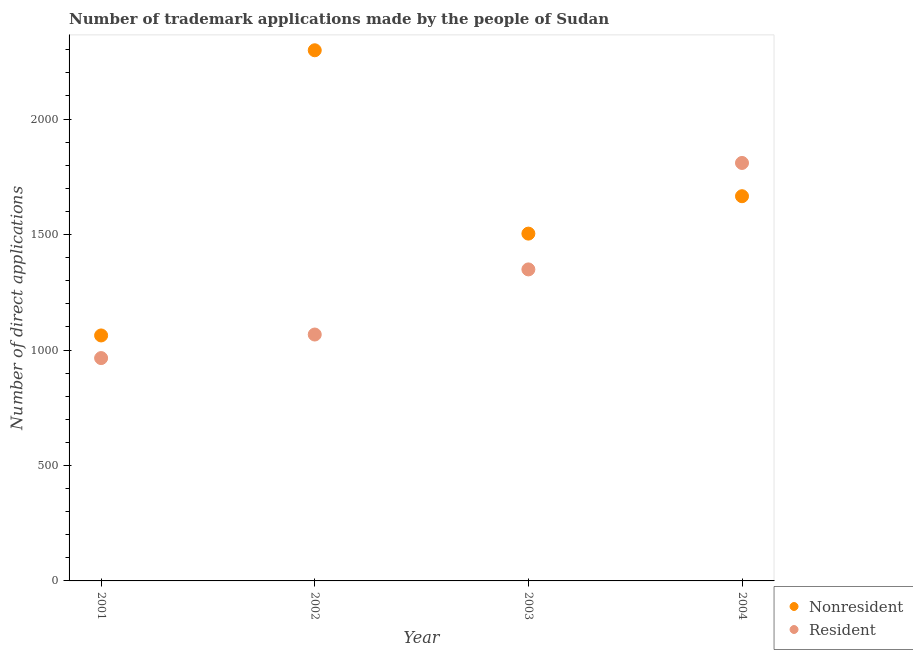How many different coloured dotlines are there?
Provide a short and direct response. 2. What is the number of trademark applications made by residents in 2003?
Your answer should be compact. 1349. Across all years, what is the maximum number of trademark applications made by non residents?
Keep it short and to the point. 2298. Across all years, what is the minimum number of trademark applications made by residents?
Give a very brief answer. 965. In which year was the number of trademark applications made by residents minimum?
Provide a short and direct response. 2001. What is the total number of trademark applications made by non residents in the graph?
Provide a short and direct response. 6531. What is the difference between the number of trademark applications made by residents in 2003 and that in 2004?
Your answer should be compact. -461. What is the difference between the number of trademark applications made by residents in 2003 and the number of trademark applications made by non residents in 2004?
Provide a succinct answer. -317. What is the average number of trademark applications made by residents per year?
Your answer should be compact. 1297.75. In the year 2004, what is the difference between the number of trademark applications made by residents and number of trademark applications made by non residents?
Provide a short and direct response. 144. What is the ratio of the number of trademark applications made by residents in 2001 to that in 2002?
Provide a short and direct response. 0.9. Is the number of trademark applications made by non residents in 2001 less than that in 2004?
Your answer should be very brief. Yes. Is the difference between the number of trademark applications made by non residents in 2001 and 2002 greater than the difference between the number of trademark applications made by residents in 2001 and 2002?
Offer a very short reply. No. What is the difference between the highest and the second highest number of trademark applications made by non residents?
Give a very brief answer. 632. What is the difference between the highest and the lowest number of trademark applications made by non residents?
Keep it short and to the point. 1235. Does the number of trademark applications made by residents monotonically increase over the years?
Provide a short and direct response. Yes. Is the number of trademark applications made by non residents strictly less than the number of trademark applications made by residents over the years?
Your answer should be very brief. No. How many dotlines are there?
Give a very brief answer. 2. Are the values on the major ticks of Y-axis written in scientific E-notation?
Ensure brevity in your answer.  No. Does the graph contain any zero values?
Provide a succinct answer. No. Does the graph contain grids?
Offer a terse response. No. Where does the legend appear in the graph?
Provide a succinct answer. Bottom right. How are the legend labels stacked?
Offer a very short reply. Vertical. What is the title of the graph?
Offer a very short reply. Number of trademark applications made by the people of Sudan. What is the label or title of the X-axis?
Your answer should be compact. Year. What is the label or title of the Y-axis?
Offer a terse response. Number of direct applications. What is the Number of direct applications in Nonresident in 2001?
Provide a short and direct response. 1063. What is the Number of direct applications of Resident in 2001?
Give a very brief answer. 965. What is the Number of direct applications in Nonresident in 2002?
Offer a terse response. 2298. What is the Number of direct applications of Resident in 2002?
Your answer should be very brief. 1067. What is the Number of direct applications in Nonresident in 2003?
Ensure brevity in your answer.  1504. What is the Number of direct applications of Resident in 2003?
Your answer should be compact. 1349. What is the Number of direct applications of Nonresident in 2004?
Make the answer very short. 1666. What is the Number of direct applications of Resident in 2004?
Your answer should be very brief. 1810. Across all years, what is the maximum Number of direct applications in Nonresident?
Your response must be concise. 2298. Across all years, what is the maximum Number of direct applications in Resident?
Make the answer very short. 1810. Across all years, what is the minimum Number of direct applications of Nonresident?
Offer a very short reply. 1063. Across all years, what is the minimum Number of direct applications of Resident?
Make the answer very short. 965. What is the total Number of direct applications in Nonresident in the graph?
Offer a terse response. 6531. What is the total Number of direct applications of Resident in the graph?
Your response must be concise. 5191. What is the difference between the Number of direct applications of Nonresident in 2001 and that in 2002?
Provide a succinct answer. -1235. What is the difference between the Number of direct applications of Resident in 2001 and that in 2002?
Ensure brevity in your answer.  -102. What is the difference between the Number of direct applications in Nonresident in 2001 and that in 2003?
Give a very brief answer. -441. What is the difference between the Number of direct applications in Resident in 2001 and that in 2003?
Keep it short and to the point. -384. What is the difference between the Number of direct applications of Nonresident in 2001 and that in 2004?
Make the answer very short. -603. What is the difference between the Number of direct applications of Resident in 2001 and that in 2004?
Ensure brevity in your answer.  -845. What is the difference between the Number of direct applications of Nonresident in 2002 and that in 2003?
Ensure brevity in your answer.  794. What is the difference between the Number of direct applications in Resident in 2002 and that in 2003?
Keep it short and to the point. -282. What is the difference between the Number of direct applications in Nonresident in 2002 and that in 2004?
Make the answer very short. 632. What is the difference between the Number of direct applications in Resident in 2002 and that in 2004?
Provide a short and direct response. -743. What is the difference between the Number of direct applications of Nonresident in 2003 and that in 2004?
Offer a terse response. -162. What is the difference between the Number of direct applications in Resident in 2003 and that in 2004?
Offer a terse response. -461. What is the difference between the Number of direct applications of Nonresident in 2001 and the Number of direct applications of Resident in 2002?
Your response must be concise. -4. What is the difference between the Number of direct applications in Nonresident in 2001 and the Number of direct applications in Resident in 2003?
Give a very brief answer. -286. What is the difference between the Number of direct applications in Nonresident in 2001 and the Number of direct applications in Resident in 2004?
Offer a very short reply. -747. What is the difference between the Number of direct applications in Nonresident in 2002 and the Number of direct applications in Resident in 2003?
Your answer should be very brief. 949. What is the difference between the Number of direct applications of Nonresident in 2002 and the Number of direct applications of Resident in 2004?
Make the answer very short. 488. What is the difference between the Number of direct applications of Nonresident in 2003 and the Number of direct applications of Resident in 2004?
Give a very brief answer. -306. What is the average Number of direct applications of Nonresident per year?
Your response must be concise. 1632.75. What is the average Number of direct applications of Resident per year?
Ensure brevity in your answer.  1297.75. In the year 2001, what is the difference between the Number of direct applications in Nonresident and Number of direct applications in Resident?
Give a very brief answer. 98. In the year 2002, what is the difference between the Number of direct applications in Nonresident and Number of direct applications in Resident?
Offer a very short reply. 1231. In the year 2003, what is the difference between the Number of direct applications of Nonresident and Number of direct applications of Resident?
Ensure brevity in your answer.  155. In the year 2004, what is the difference between the Number of direct applications in Nonresident and Number of direct applications in Resident?
Provide a succinct answer. -144. What is the ratio of the Number of direct applications in Nonresident in 2001 to that in 2002?
Your response must be concise. 0.46. What is the ratio of the Number of direct applications of Resident in 2001 to that in 2002?
Give a very brief answer. 0.9. What is the ratio of the Number of direct applications in Nonresident in 2001 to that in 2003?
Your response must be concise. 0.71. What is the ratio of the Number of direct applications of Resident in 2001 to that in 2003?
Offer a very short reply. 0.72. What is the ratio of the Number of direct applications of Nonresident in 2001 to that in 2004?
Keep it short and to the point. 0.64. What is the ratio of the Number of direct applications of Resident in 2001 to that in 2004?
Keep it short and to the point. 0.53. What is the ratio of the Number of direct applications of Nonresident in 2002 to that in 2003?
Make the answer very short. 1.53. What is the ratio of the Number of direct applications in Resident in 2002 to that in 2003?
Provide a succinct answer. 0.79. What is the ratio of the Number of direct applications of Nonresident in 2002 to that in 2004?
Your response must be concise. 1.38. What is the ratio of the Number of direct applications in Resident in 2002 to that in 2004?
Provide a short and direct response. 0.59. What is the ratio of the Number of direct applications of Nonresident in 2003 to that in 2004?
Give a very brief answer. 0.9. What is the ratio of the Number of direct applications of Resident in 2003 to that in 2004?
Ensure brevity in your answer.  0.75. What is the difference between the highest and the second highest Number of direct applications of Nonresident?
Offer a very short reply. 632. What is the difference between the highest and the second highest Number of direct applications in Resident?
Provide a short and direct response. 461. What is the difference between the highest and the lowest Number of direct applications in Nonresident?
Make the answer very short. 1235. What is the difference between the highest and the lowest Number of direct applications of Resident?
Offer a terse response. 845. 